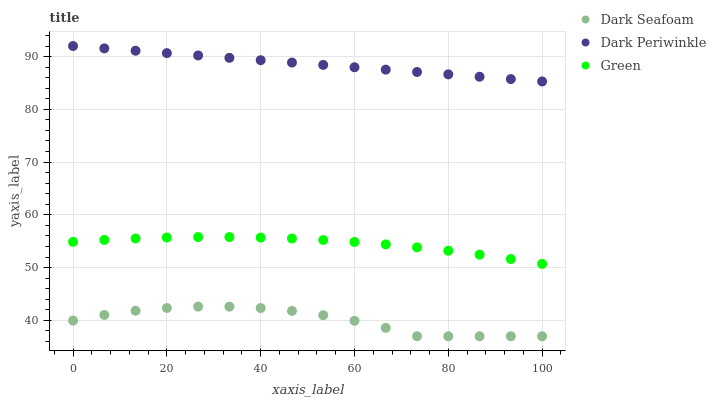Does Dark Seafoam have the minimum area under the curve?
Answer yes or no. Yes. Does Dark Periwinkle have the maximum area under the curve?
Answer yes or no. Yes. Does Green have the minimum area under the curve?
Answer yes or no. No. Does Green have the maximum area under the curve?
Answer yes or no. No. Is Dark Periwinkle the smoothest?
Answer yes or no. Yes. Is Dark Seafoam the roughest?
Answer yes or no. Yes. Is Green the smoothest?
Answer yes or no. No. Is Green the roughest?
Answer yes or no. No. Does Dark Seafoam have the lowest value?
Answer yes or no. Yes. Does Green have the lowest value?
Answer yes or no. No. Does Dark Periwinkle have the highest value?
Answer yes or no. Yes. Does Green have the highest value?
Answer yes or no. No. Is Dark Seafoam less than Dark Periwinkle?
Answer yes or no. Yes. Is Dark Periwinkle greater than Dark Seafoam?
Answer yes or no. Yes. Does Dark Seafoam intersect Dark Periwinkle?
Answer yes or no. No. 